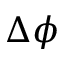Convert formula to latex. <formula><loc_0><loc_0><loc_500><loc_500>\Delta \phi</formula> 